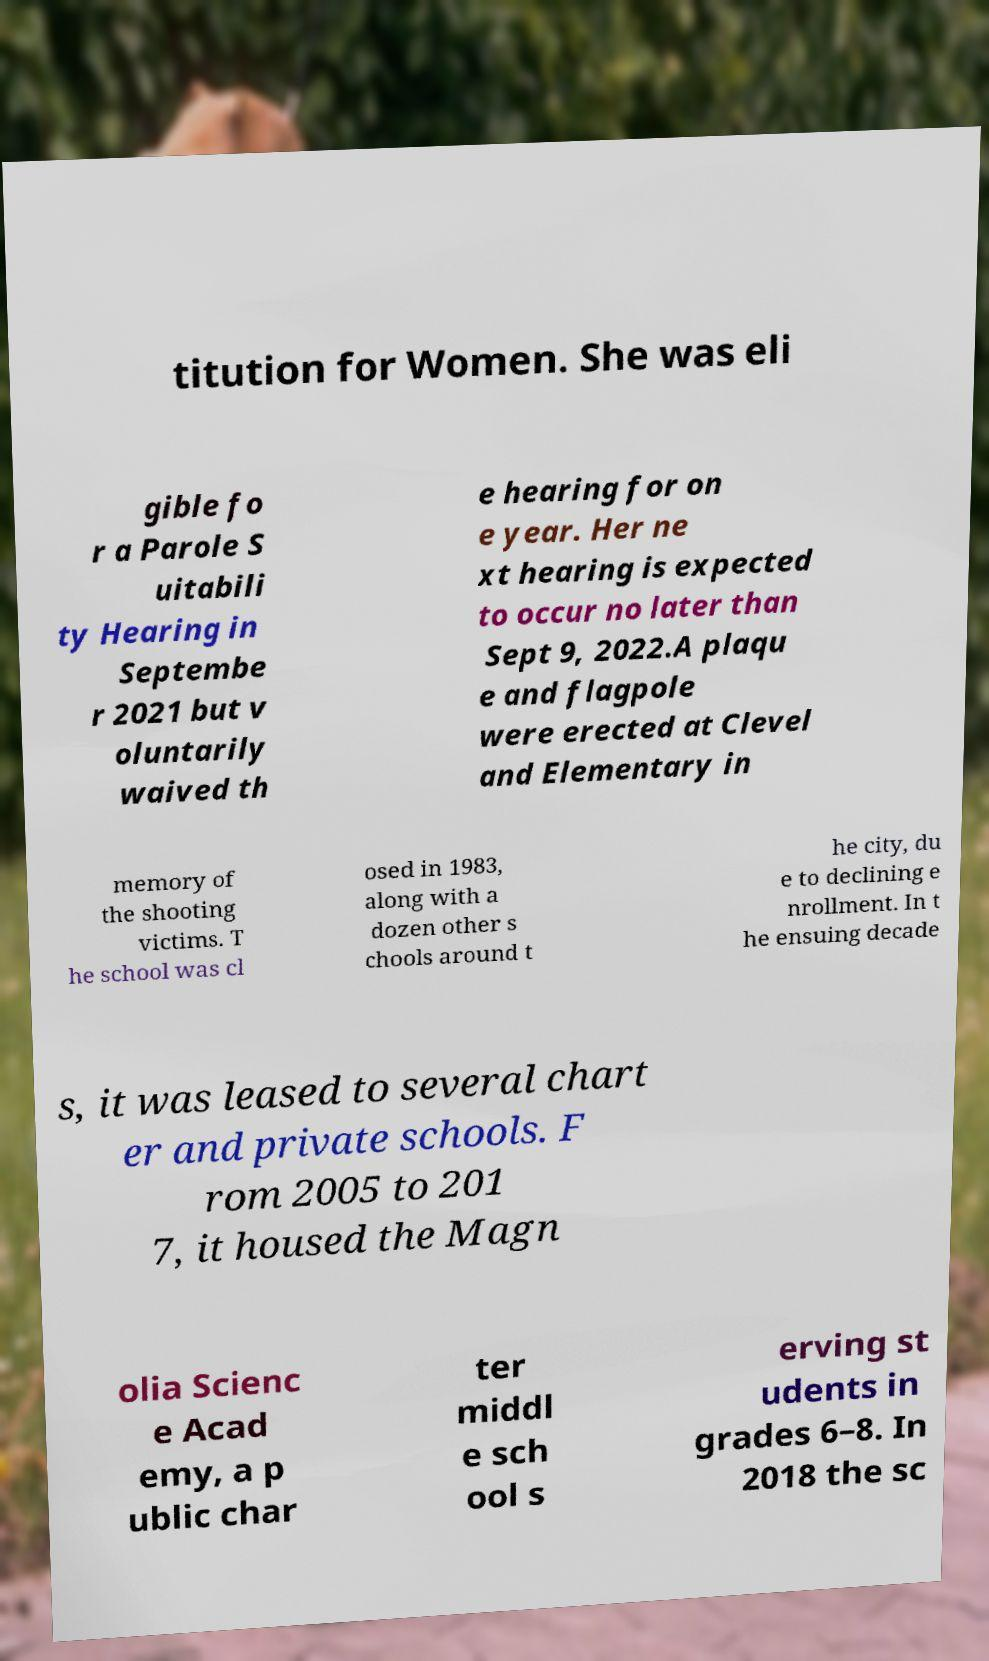Could you assist in decoding the text presented in this image and type it out clearly? titution for Women. She was eli gible fo r a Parole S uitabili ty Hearing in Septembe r 2021 but v oluntarily waived th e hearing for on e year. Her ne xt hearing is expected to occur no later than Sept 9, 2022.A plaqu e and flagpole were erected at Clevel and Elementary in memory of the shooting victims. T he school was cl osed in 1983, along with a dozen other s chools around t he city, du e to declining e nrollment. In t he ensuing decade s, it was leased to several chart er and private schools. F rom 2005 to 201 7, it housed the Magn olia Scienc e Acad emy, a p ublic char ter middl e sch ool s erving st udents in grades 6–8. In 2018 the sc 